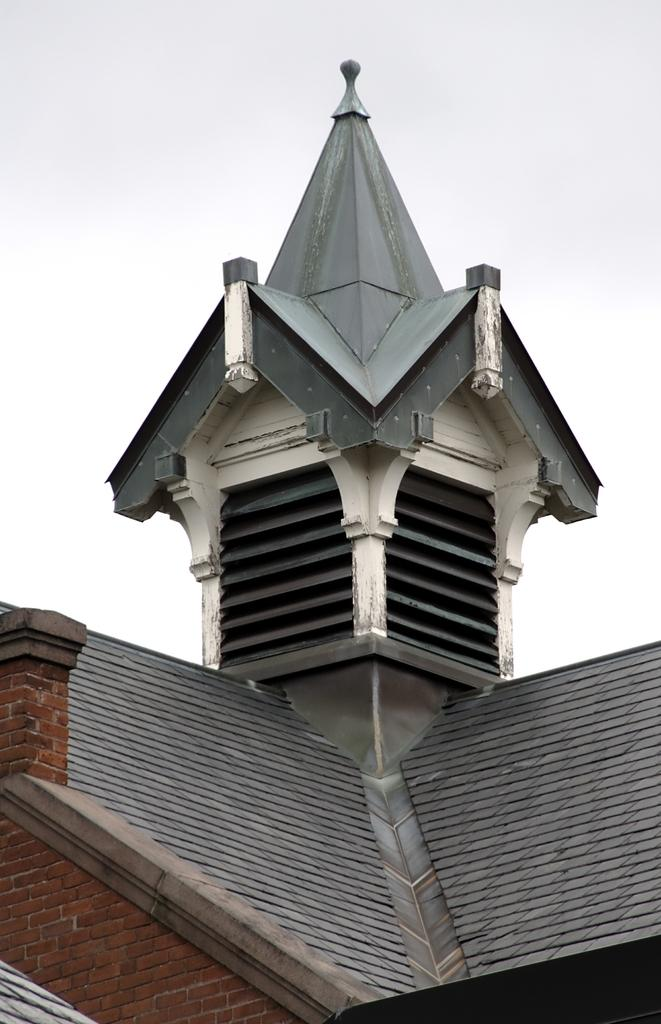Where was the image taken? The image was taken outdoors. What can be seen in the sky in the image? The sky with clouds is visible at the top of the image. What type of structure is present in the image? There is an architecture with walls in the middle of the image. How many grapes are hanging from the walls in the image? There are no grapes present in the image; it features an architecture with walls and a sky with clouds. 